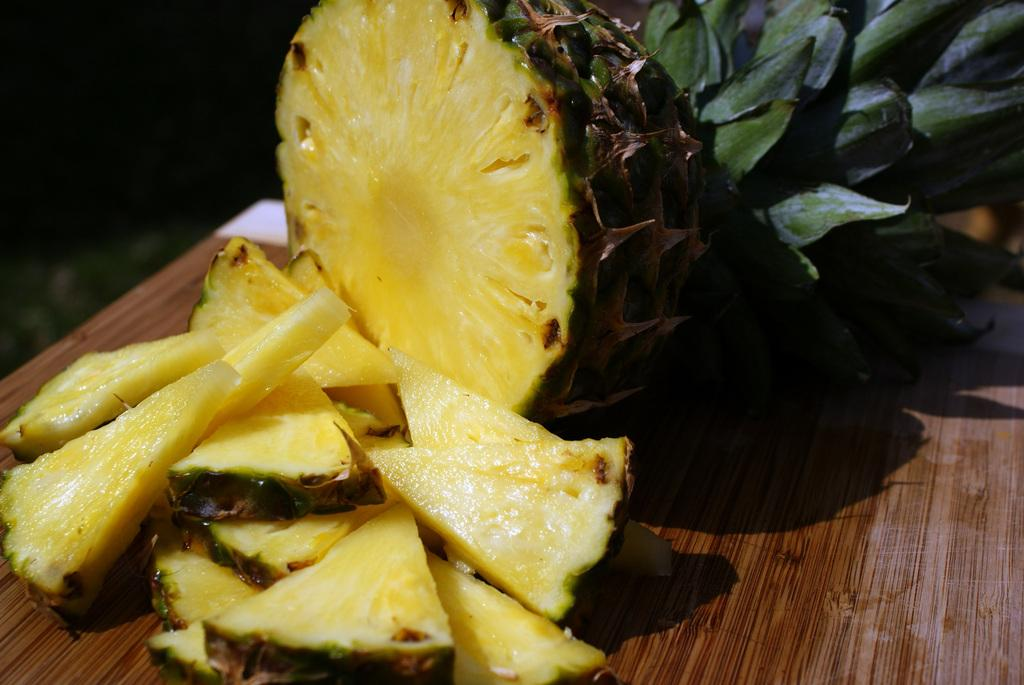What type of food is present in the image? There is fruit in the image. Where is the fruit located in the image? The fruit is in the center of the image. What is the color of the surface beneath the fruit? The surface beneath the fruit is brown in color. What type of fork is used to serve the loaf in the image? There is no loaf or fork present in the image; it only features fruit in the center of the image. 